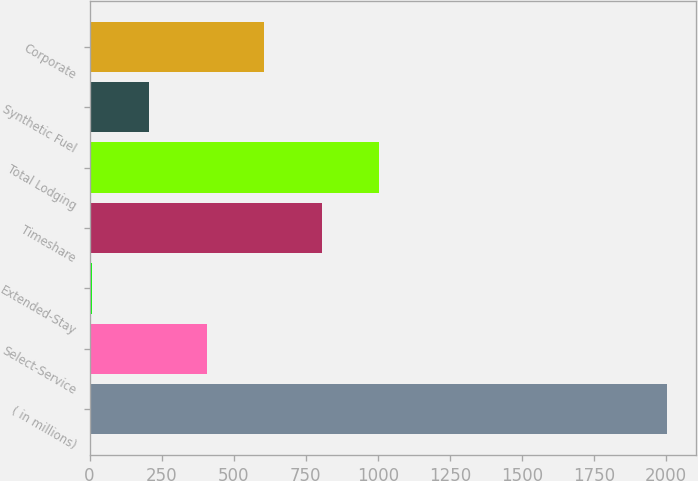Convert chart to OTSL. <chart><loc_0><loc_0><loc_500><loc_500><bar_chart><fcel>( in millions)<fcel>Select-Service<fcel>Extended-Stay<fcel>Timeshare<fcel>Total Lodging<fcel>Synthetic Fuel<fcel>Corporate<nl><fcel>2005<fcel>406.6<fcel>7<fcel>806.2<fcel>1006<fcel>206.8<fcel>606.4<nl></chart> 